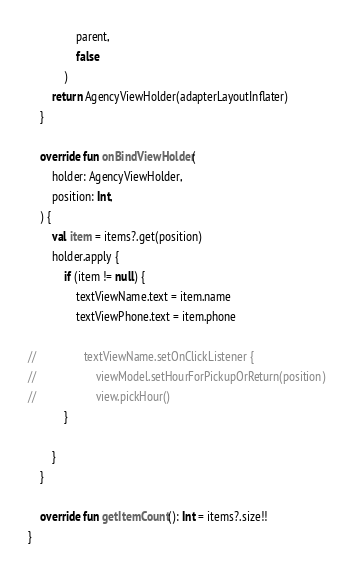Convert code to text. <code><loc_0><loc_0><loc_500><loc_500><_Kotlin_>                parent,
                false
            )
        return AgencyViewHolder(adapterLayoutInflater)
    }

    override fun onBindViewHolder(
        holder: AgencyViewHolder,
        position: Int,
    ) {
        val item = items?.get(position)
        holder.apply {
            if (item != null) {
                textViewName.text = item.name
                textViewPhone.text = item.phone

//                textViewName.setOnClickListener {
//                    viewModel.setHourForPickupOrReturn(position)
//                    view.pickHour()
            }

        }
    }

    override fun getItemCount(): Int = items?.size!!
}
</code> 